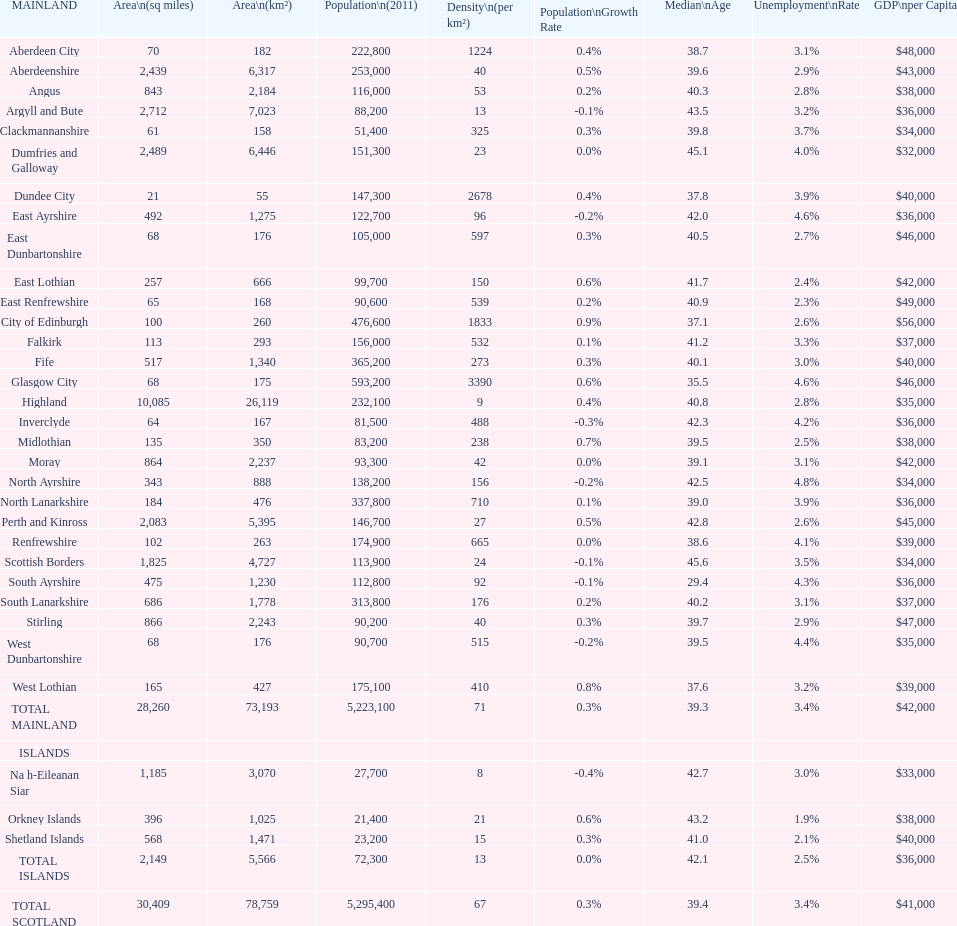What is the total size of east lothian, angus, and dundee city in terms of area? 1121. 